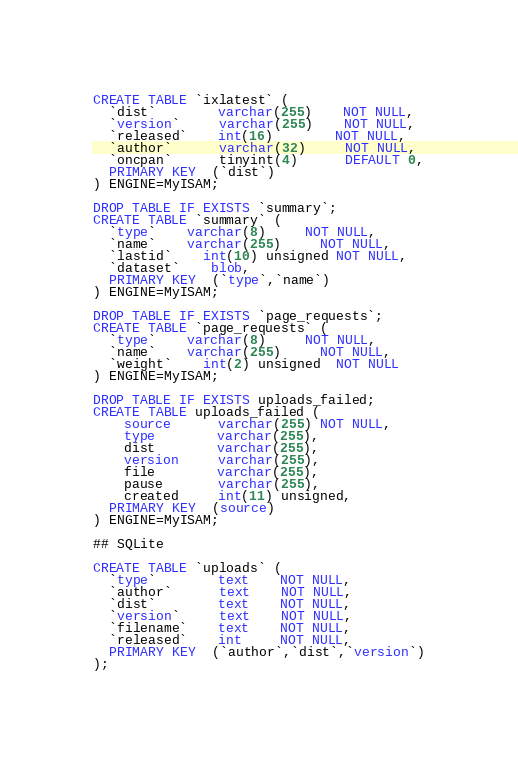Convert code to text. <code><loc_0><loc_0><loc_500><loc_500><_SQL_>CREATE TABLE `ixlatest` (
  `dist`        varchar(255)    NOT NULL,
  `version`     varchar(255)    NOT NULL,
  `released`    int(16)		NOT NULL,
  `author`      varchar(32)     NOT NULL,
  `oncpan`      tinyint(4)      DEFAULT 0,
  PRIMARY KEY  (`dist`)
) ENGINE=MyISAM;

DROP TABLE IF EXISTS `summary`;
CREATE TABLE `summary` (
  `type`	varchar(8)	 NOT NULL,
  `name`	varchar(255)     NOT NULL,
  `lastid`	int(10) unsigned NOT NULL,
  `dataset`	blob,
  PRIMARY KEY  (`type`,`name`)
) ENGINE=MyISAM;

DROP TABLE IF EXISTS `page_requests`;
CREATE TABLE `page_requests` (
  `type`	varchar(8)	 NOT NULL,
  `name`	varchar(255)     NOT NULL,
  `weight`	int(2) unsigned  NOT NULL
) ENGINE=MyISAM;

DROP TABLE IF EXISTS uploads_failed;
CREATE TABLE uploads_failed (
    source      varchar(255) NOT NULL,
    type        varchar(255),
    dist        varchar(255),
    version     varchar(255),
    file        varchar(255),
    pause       varchar(255),
    created     int(11) unsigned,
  PRIMARY KEY  (source)
) ENGINE=MyISAM;

## SQLite

CREATE TABLE `uploads` (
  `type`        text    NOT NULL,
  `author`      text    NOT NULL,
  `dist`        text    NOT NULL,
  `version`     text    NOT NULL,
  `filename`    text    NOT NULL,
  `released`    int     NOT NULL,
  PRIMARY KEY  (`author`,`dist`,`version`)
);
</code> 